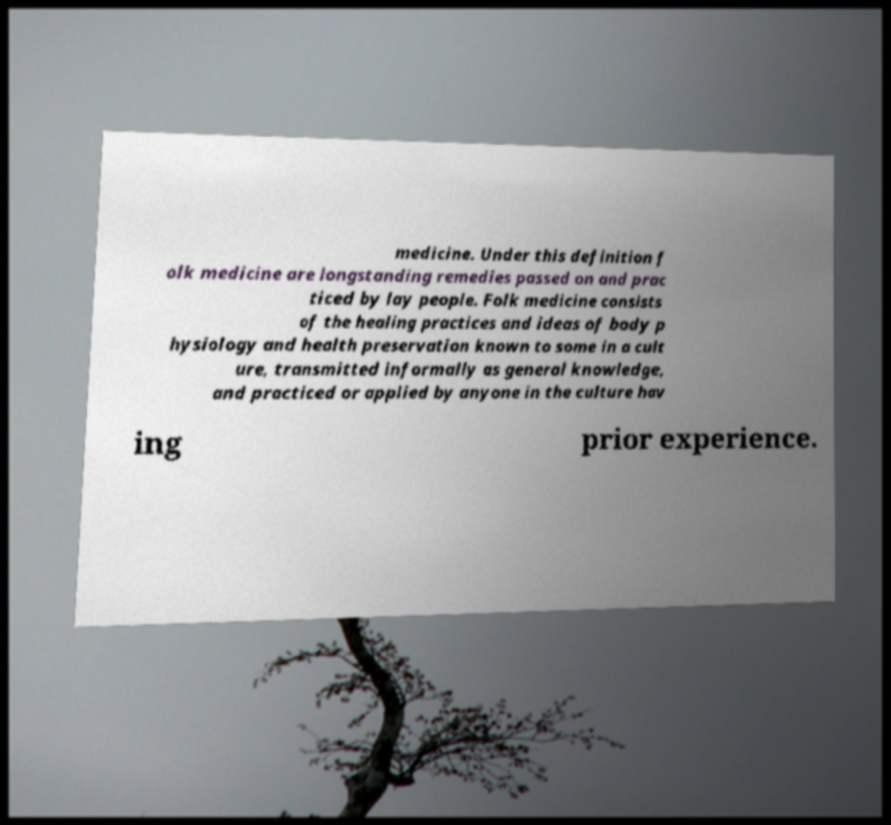Can you read and provide the text displayed in the image?This photo seems to have some interesting text. Can you extract and type it out for me? medicine. Under this definition f olk medicine are longstanding remedies passed on and prac ticed by lay people. Folk medicine consists of the healing practices and ideas of body p hysiology and health preservation known to some in a cult ure, transmitted informally as general knowledge, and practiced or applied by anyone in the culture hav ing prior experience. 